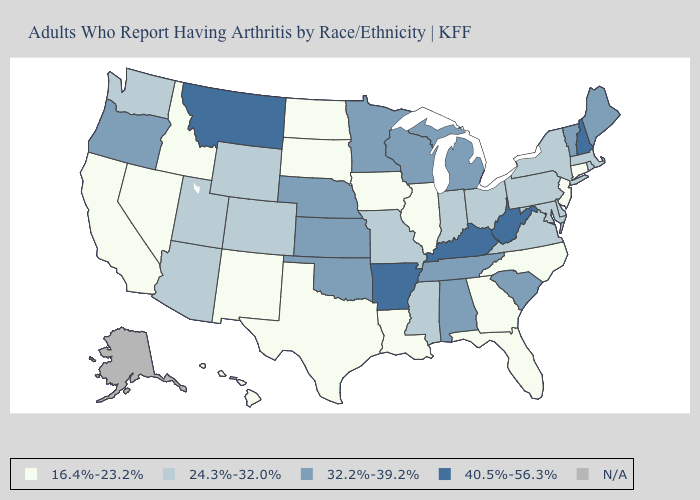What is the lowest value in the South?
Short answer required. 16.4%-23.2%. Which states have the highest value in the USA?
Give a very brief answer. Arkansas, Kentucky, Montana, New Hampshire, West Virginia. Name the states that have a value in the range 16.4%-23.2%?
Short answer required. California, Connecticut, Florida, Georgia, Hawaii, Idaho, Illinois, Iowa, Louisiana, Nevada, New Jersey, New Mexico, North Carolina, North Dakota, South Dakota, Texas. Which states hav the highest value in the Northeast?
Write a very short answer. New Hampshire. Which states hav the highest value in the West?
Keep it brief. Montana. What is the value of Pennsylvania?
Concise answer only. 24.3%-32.0%. How many symbols are there in the legend?
Give a very brief answer. 5. Name the states that have a value in the range 16.4%-23.2%?
Concise answer only. California, Connecticut, Florida, Georgia, Hawaii, Idaho, Illinois, Iowa, Louisiana, Nevada, New Jersey, New Mexico, North Carolina, North Dakota, South Dakota, Texas. What is the highest value in the USA?
Keep it brief. 40.5%-56.3%. What is the highest value in the South ?
Be succinct. 40.5%-56.3%. Among the states that border Florida , does Alabama have the lowest value?
Write a very short answer. No. Is the legend a continuous bar?
Be succinct. No. Name the states that have a value in the range 24.3%-32.0%?
Write a very short answer. Arizona, Colorado, Delaware, Indiana, Maryland, Massachusetts, Mississippi, Missouri, New York, Ohio, Pennsylvania, Rhode Island, Utah, Virginia, Washington, Wyoming. What is the highest value in the USA?
Give a very brief answer. 40.5%-56.3%. 